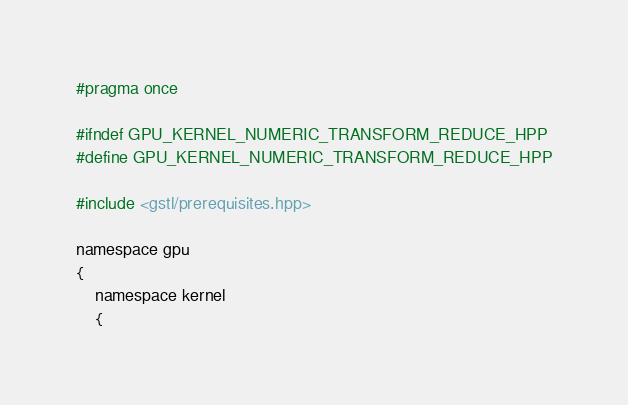<code> <loc_0><loc_0><loc_500><loc_500><_Cuda_>#pragma once

#ifndef GPU_KERNEL_NUMERIC_TRANSFORM_REDUCE_HPP
#define GPU_KERNEL_NUMERIC_TRANSFORM_REDUCE_HPP

#include <gstl/prerequisites.hpp>

namespace gpu
{
	namespace kernel
	{
</code> 